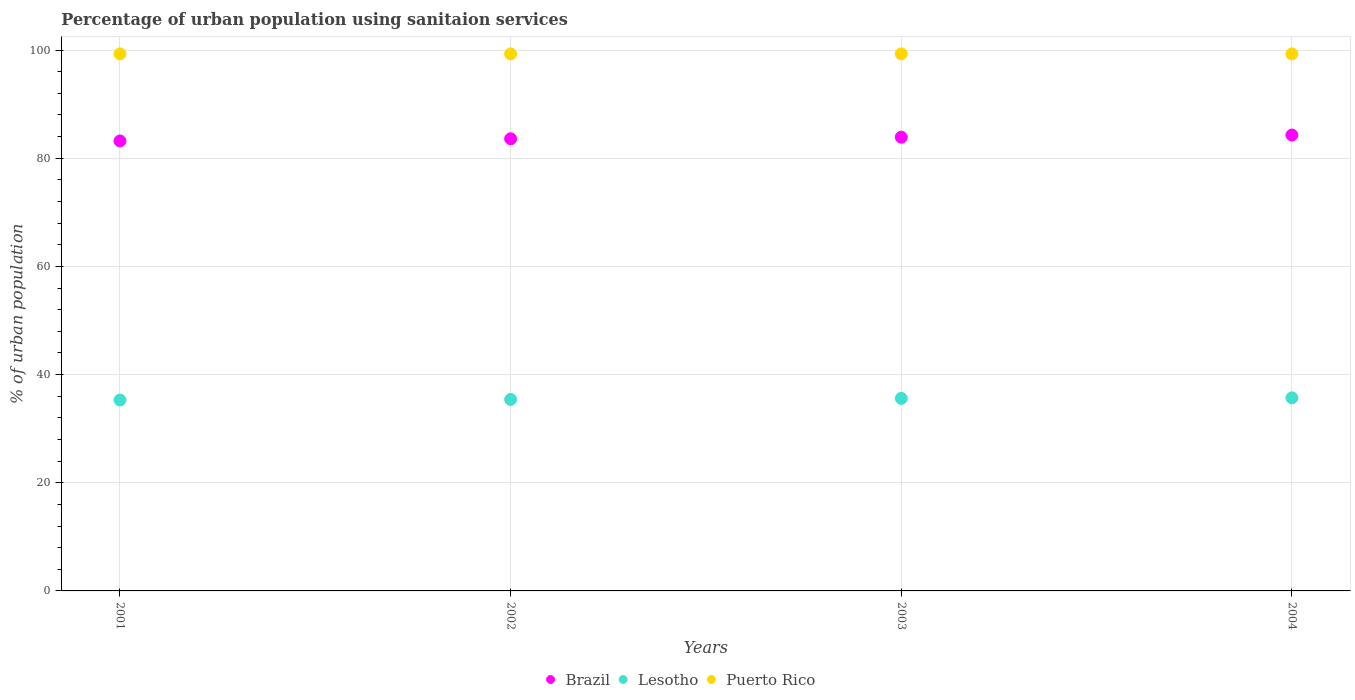What is the percentage of urban population using sanitaion services in Lesotho in 2003?
Offer a very short reply. 35.6. Across all years, what is the maximum percentage of urban population using sanitaion services in Puerto Rico?
Your answer should be very brief. 99.3. Across all years, what is the minimum percentage of urban population using sanitaion services in Lesotho?
Give a very brief answer. 35.3. In which year was the percentage of urban population using sanitaion services in Lesotho maximum?
Your answer should be very brief. 2004. What is the total percentage of urban population using sanitaion services in Brazil in the graph?
Offer a terse response. 335. What is the difference between the percentage of urban population using sanitaion services in Brazil in 2001 and that in 2004?
Offer a terse response. -1.1. What is the difference between the percentage of urban population using sanitaion services in Brazil in 2003 and the percentage of urban population using sanitaion services in Puerto Rico in 2001?
Give a very brief answer. -15.4. What is the average percentage of urban population using sanitaion services in Lesotho per year?
Your response must be concise. 35.5. In the year 2004, what is the difference between the percentage of urban population using sanitaion services in Lesotho and percentage of urban population using sanitaion services in Puerto Rico?
Your answer should be very brief. -63.6. In how many years, is the percentage of urban population using sanitaion services in Puerto Rico greater than 28 %?
Your answer should be very brief. 4. What is the ratio of the percentage of urban population using sanitaion services in Brazil in 2001 to that in 2003?
Your answer should be very brief. 0.99. Is the difference between the percentage of urban population using sanitaion services in Lesotho in 2001 and 2004 greater than the difference between the percentage of urban population using sanitaion services in Puerto Rico in 2001 and 2004?
Offer a terse response. No. What is the difference between the highest and the second highest percentage of urban population using sanitaion services in Brazil?
Provide a succinct answer. 0.4. What is the difference between the highest and the lowest percentage of urban population using sanitaion services in Brazil?
Your answer should be very brief. 1.1. Is the sum of the percentage of urban population using sanitaion services in Puerto Rico in 2001 and 2004 greater than the maximum percentage of urban population using sanitaion services in Brazil across all years?
Your response must be concise. Yes. Is it the case that in every year, the sum of the percentage of urban population using sanitaion services in Brazil and percentage of urban population using sanitaion services in Lesotho  is greater than the percentage of urban population using sanitaion services in Puerto Rico?
Provide a short and direct response. Yes. Is the percentage of urban population using sanitaion services in Puerto Rico strictly greater than the percentage of urban population using sanitaion services in Lesotho over the years?
Your answer should be very brief. Yes. How many years are there in the graph?
Make the answer very short. 4. Does the graph contain grids?
Your response must be concise. Yes. Where does the legend appear in the graph?
Offer a terse response. Bottom center. How many legend labels are there?
Keep it short and to the point. 3. How are the legend labels stacked?
Make the answer very short. Horizontal. What is the title of the graph?
Offer a very short reply. Percentage of urban population using sanitaion services. Does "Honduras" appear as one of the legend labels in the graph?
Give a very brief answer. No. What is the label or title of the X-axis?
Keep it short and to the point. Years. What is the label or title of the Y-axis?
Provide a short and direct response. % of urban population. What is the % of urban population of Brazil in 2001?
Provide a succinct answer. 83.2. What is the % of urban population of Lesotho in 2001?
Offer a very short reply. 35.3. What is the % of urban population in Puerto Rico in 2001?
Keep it short and to the point. 99.3. What is the % of urban population of Brazil in 2002?
Provide a succinct answer. 83.6. What is the % of urban population in Lesotho in 2002?
Make the answer very short. 35.4. What is the % of urban population of Puerto Rico in 2002?
Make the answer very short. 99.3. What is the % of urban population of Brazil in 2003?
Ensure brevity in your answer.  83.9. What is the % of urban population in Lesotho in 2003?
Offer a terse response. 35.6. What is the % of urban population in Puerto Rico in 2003?
Your answer should be compact. 99.3. What is the % of urban population of Brazil in 2004?
Give a very brief answer. 84.3. What is the % of urban population in Lesotho in 2004?
Ensure brevity in your answer.  35.7. What is the % of urban population of Puerto Rico in 2004?
Your response must be concise. 99.3. Across all years, what is the maximum % of urban population in Brazil?
Your response must be concise. 84.3. Across all years, what is the maximum % of urban population of Lesotho?
Your answer should be very brief. 35.7. Across all years, what is the maximum % of urban population of Puerto Rico?
Offer a terse response. 99.3. Across all years, what is the minimum % of urban population in Brazil?
Make the answer very short. 83.2. Across all years, what is the minimum % of urban population of Lesotho?
Offer a terse response. 35.3. Across all years, what is the minimum % of urban population in Puerto Rico?
Offer a very short reply. 99.3. What is the total % of urban population of Brazil in the graph?
Your answer should be compact. 335. What is the total % of urban population in Lesotho in the graph?
Provide a short and direct response. 142. What is the total % of urban population of Puerto Rico in the graph?
Your answer should be very brief. 397.2. What is the difference between the % of urban population of Brazil in 2001 and that in 2002?
Provide a short and direct response. -0.4. What is the difference between the % of urban population in Brazil in 2001 and that in 2003?
Your answer should be compact. -0.7. What is the difference between the % of urban population of Lesotho in 2001 and that in 2003?
Offer a terse response. -0.3. What is the difference between the % of urban population of Brazil in 2001 and that in 2004?
Your answer should be compact. -1.1. What is the difference between the % of urban population in Lesotho in 2001 and that in 2004?
Your answer should be compact. -0.4. What is the difference between the % of urban population of Brazil in 2002 and that in 2003?
Your answer should be very brief. -0.3. What is the difference between the % of urban population of Puerto Rico in 2002 and that in 2003?
Keep it short and to the point. 0. What is the difference between the % of urban population in Brazil in 2002 and that in 2004?
Offer a very short reply. -0.7. What is the difference between the % of urban population in Lesotho in 2002 and that in 2004?
Ensure brevity in your answer.  -0.3. What is the difference between the % of urban population of Puerto Rico in 2002 and that in 2004?
Make the answer very short. 0. What is the difference between the % of urban population of Lesotho in 2003 and that in 2004?
Your response must be concise. -0.1. What is the difference between the % of urban population of Brazil in 2001 and the % of urban population of Lesotho in 2002?
Provide a succinct answer. 47.8. What is the difference between the % of urban population of Brazil in 2001 and the % of urban population of Puerto Rico in 2002?
Make the answer very short. -16.1. What is the difference between the % of urban population in Lesotho in 2001 and the % of urban population in Puerto Rico in 2002?
Keep it short and to the point. -64. What is the difference between the % of urban population in Brazil in 2001 and the % of urban population in Lesotho in 2003?
Offer a very short reply. 47.6. What is the difference between the % of urban population of Brazil in 2001 and the % of urban population of Puerto Rico in 2003?
Keep it short and to the point. -16.1. What is the difference between the % of urban population of Lesotho in 2001 and the % of urban population of Puerto Rico in 2003?
Provide a short and direct response. -64. What is the difference between the % of urban population of Brazil in 2001 and the % of urban population of Lesotho in 2004?
Ensure brevity in your answer.  47.5. What is the difference between the % of urban population in Brazil in 2001 and the % of urban population in Puerto Rico in 2004?
Ensure brevity in your answer.  -16.1. What is the difference between the % of urban population in Lesotho in 2001 and the % of urban population in Puerto Rico in 2004?
Make the answer very short. -64. What is the difference between the % of urban population of Brazil in 2002 and the % of urban population of Lesotho in 2003?
Your response must be concise. 48. What is the difference between the % of urban population in Brazil in 2002 and the % of urban population in Puerto Rico in 2003?
Your answer should be very brief. -15.7. What is the difference between the % of urban population in Lesotho in 2002 and the % of urban population in Puerto Rico in 2003?
Offer a very short reply. -63.9. What is the difference between the % of urban population in Brazil in 2002 and the % of urban population in Lesotho in 2004?
Provide a short and direct response. 47.9. What is the difference between the % of urban population of Brazil in 2002 and the % of urban population of Puerto Rico in 2004?
Make the answer very short. -15.7. What is the difference between the % of urban population in Lesotho in 2002 and the % of urban population in Puerto Rico in 2004?
Your answer should be very brief. -63.9. What is the difference between the % of urban population in Brazil in 2003 and the % of urban population in Lesotho in 2004?
Give a very brief answer. 48.2. What is the difference between the % of urban population of Brazil in 2003 and the % of urban population of Puerto Rico in 2004?
Offer a very short reply. -15.4. What is the difference between the % of urban population in Lesotho in 2003 and the % of urban population in Puerto Rico in 2004?
Make the answer very short. -63.7. What is the average % of urban population in Brazil per year?
Offer a very short reply. 83.75. What is the average % of urban population in Lesotho per year?
Your answer should be compact. 35.5. What is the average % of urban population of Puerto Rico per year?
Offer a very short reply. 99.3. In the year 2001, what is the difference between the % of urban population of Brazil and % of urban population of Lesotho?
Ensure brevity in your answer.  47.9. In the year 2001, what is the difference between the % of urban population of Brazil and % of urban population of Puerto Rico?
Make the answer very short. -16.1. In the year 2001, what is the difference between the % of urban population of Lesotho and % of urban population of Puerto Rico?
Provide a short and direct response. -64. In the year 2002, what is the difference between the % of urban population in Brazil and % of urban population in Lesotho?
Your answer should be very brief. 48.2. In the year 2002, what is the difference between the % of urban population of Brazil and % of urban population of Puerto Rico?
Provide a succinct answer. -15.7. In the year 2002, what is the difference between the % of urban population in Lesotho and % of urban population in Puerto Rico?
Give a very brief answer. -63.9. In the year 2003, what is the difference between the % of urban population of Brazil and % of urban population of Lesotho?
Keep it short and to the point. 48.3. In the year 2003, what is the difference between the % of urban population in Brazil and % of urban population in Puerto Rico?
Your answer should be very brief. -15.4. In the year 2003, what is the difference between the % of urban population in Lesotho and % of urban population in Puerto Rico?
Provide a short and direct response. -63.7. In the year 2004, what is the difference between the % of urban population of Brazil and % of urban population of Lesotho?
Give a very brief answer. 48.6. In the year 2004, what is the difference between the % of urban population of Brazil and % of urban population of Puerto Rico?
Make the answer very short. -15. In the year 2004, what is the difference between the % of urban population of Lesotho and % of urban population of Puerto Rico?
Your response must be concise. -63.6. What is the ratio of the % of urban population in Puerto Rico in 2001 to that in 2002?
Give a very brief answer. 1. What is the ratio of the % of urban population of Brazil in 2001 to that in 2003?
Keep it short and to the point. 0.99. What is the ratio of the % of urban population in Puerto Rico in 2001 to that in 2003?
Ensure brevity in your answer.  1. What is the ratio of the % of urban population in Brazil in 2001 to that in 2004?
Make the answer very short. 0.99. What is the ratio of the % of urban population of Brazil in 2002 to that in 2003?
Provide a succinct answer. 1. What is the ratio of the % of urban population of Lesotho in 2002 to that in 2004?
Your response must be concise. 0.99. What is the ratio of the % of urban population of Brazil in 2003 to that in 2004?
Give a very brief answer. 1. What is the ratio of the % of urban population in Puerto Rico in 2003 to that in 2004?
Offer a terse response. 1. What is the difference between the highest and the second highest % of urban population of Brazil?
Offer a terse response. 0.4. What is the difference between the highest and the second highest % of urban population in Lesotho?
Make the answer very short. 0.1. What is the difference between the highest and the second highest % of urban population in Puerto Rico?
Offer a very short reply. 0. What is the difference between the highest and the lowest % of urban population of Puerto Rico?
Offer a very short reply. 0. 